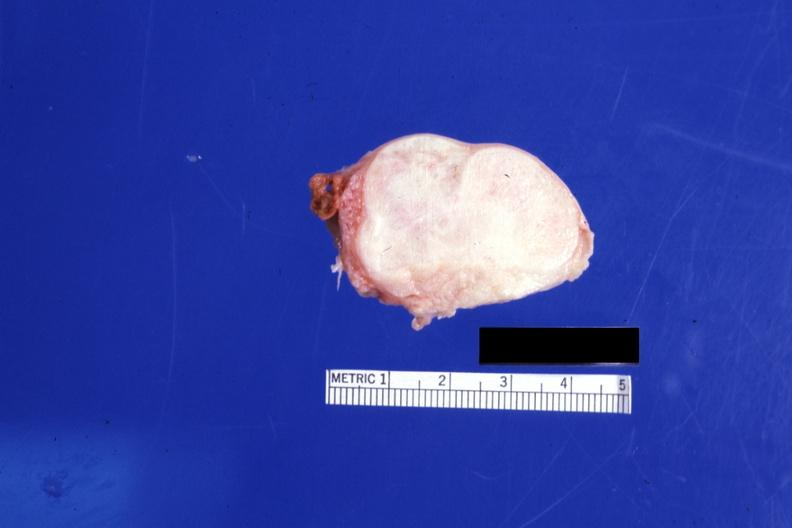what is present?
Answer the question using a single word or phrase. Ovary 